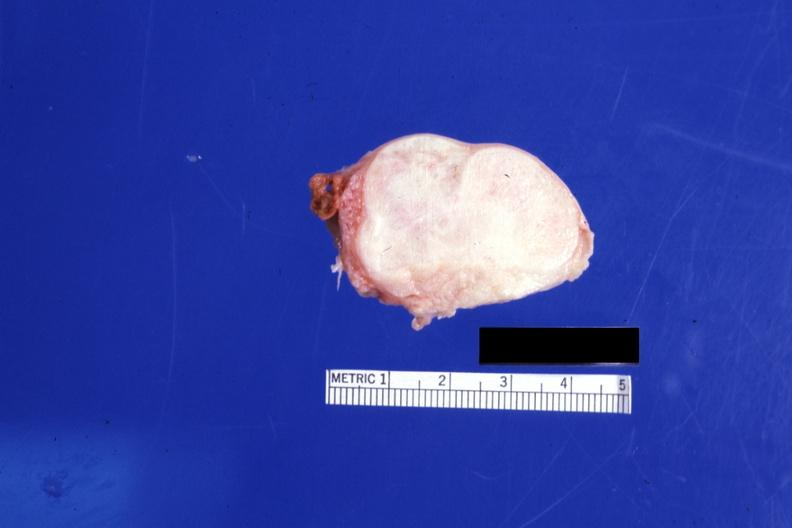what is present?
Answer the question using a single word or phrase. Ovary 